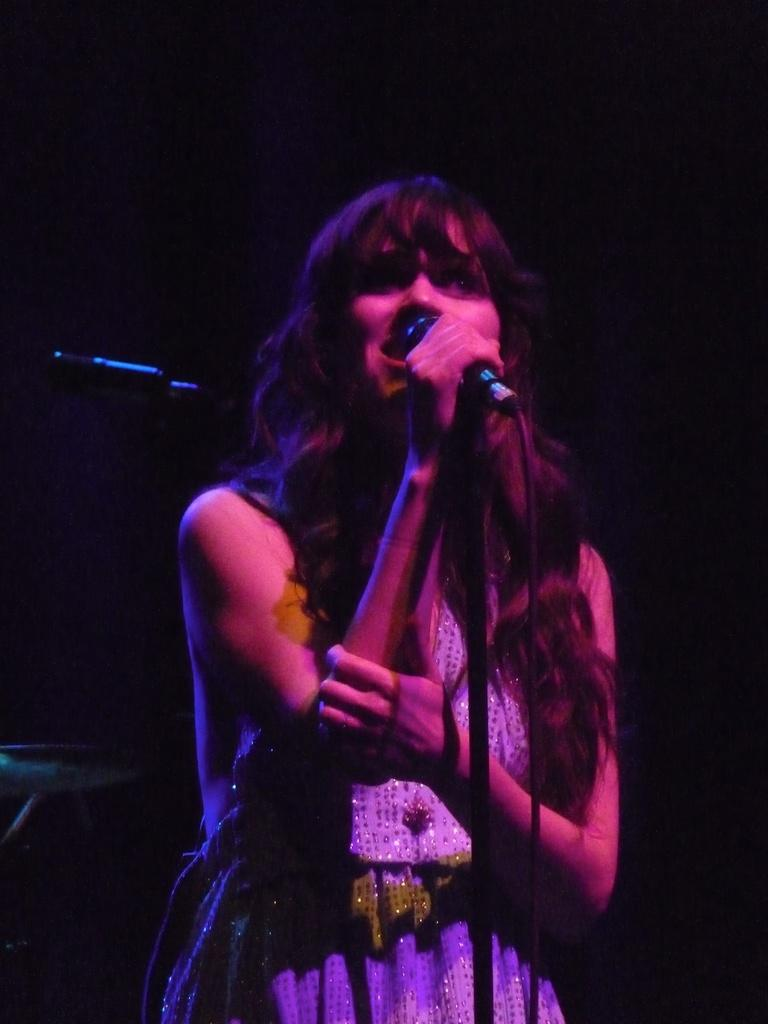What is the main subject of the image? There is a woman standing in the image. What object is present near the woman? There is a microphone with a microphone stand in the image. What can be observed about the background of the image? The background of the image is dark. How many dogs are sitting at the dinner table in the image? There are no dogs or dinner table present in the image. What type of branch is hanging from the ceiling in the image? There is no branch visible in the image. 